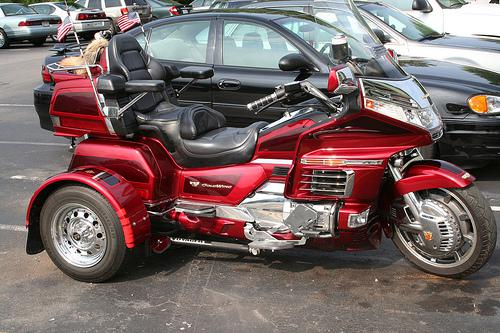Question: what color is the pavement?
Choices:
A. Black.
B. Red.
C. Grey.
D. White.
Answer with the letter. Answer: A Question: where is the motorcycle?
Choices:
A. On the pavement.
B. In the garage.
C. On the road.
D. In the parking lot.
Answer with the letter. Answer: A Question: what is on the motorcycle?
Choices:
A. Flags.
B. Mirrors.
C. Lights.
D. Seats.
Answer with the letter. Answer: A 